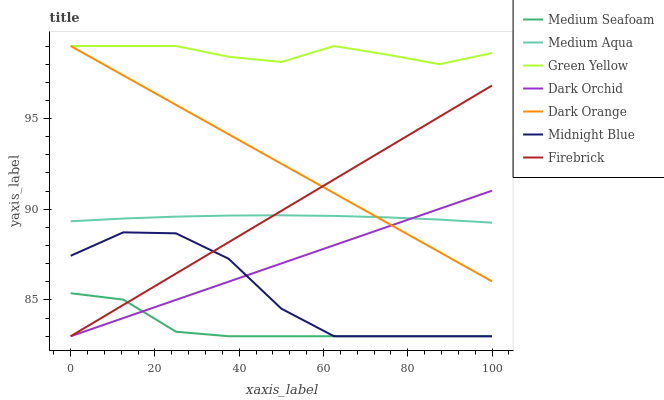Does Medium Seafoam have the minimum area under the curve?
Answer yes or no. Yes. Does Green Yellow have the maximum area under the curve?
Answer yes or no. Yes. Does Midnight Blue have the minimum area under the curve?
Answer yes or no. No. Does Midnight Blue have the maximum area under the curve?
Answer yes or no. No. Is Firebrick the smoothest?
Answer yes or no. Yes. Is Midnight Blue the roughest?
Answer yes or no. Yes. Is Midnight Blue the smoothest?
Answer yes or no. No. Is Firebrick the roughest?
Answer yes or no. No. Does Midnight Blue have the lowest value?
Answer yes or no. Yes. Does Medium Aqua have the lowest value?
Answer yes or no. No. Does Green Yellow have the highest value?
Answer yes or no. Yes. Does Midnight Blue have the highest value?
Answer yes or no. No. Is Dark Orchid less than Green Yellow?
Answer yes or no. Yes. Is Green Yellow greater than Medium Aqua?
Answer yes or no. Yes. Does Dark Orange intersect Dark Orchid?
Answer yes or no. Yes. Is Dark Orange less than Dark Orchid?
Answer yes or no. No. Is Dark Orange greater than Dark Orchid?
Answer yes or no. No. Does Dark Orchid intersect Green Yellow?
Answer yes or no. No. 